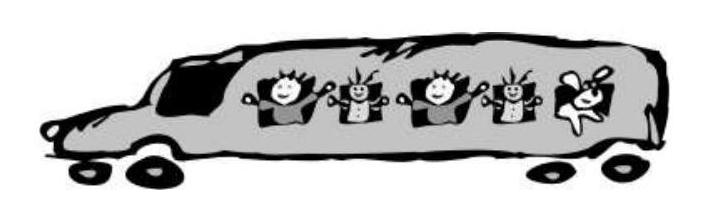A trip of the pupils to the zoo took 135 minutes. How many hours and minutes does it make? Choices: ['3 h 5 min', '2 h 15 min', '1 h 35 min', '2 h 35 min', '3 h 35 min'] The correct answer is '2 h 15 min'. To convert 135 minutes into hours and minutes, you divide 135 by 60, which gives you 2 hours because 60 minutes make up 1 hour. The remainder is 15 minutes. Therefore, 135 minutes is equivalent to 2 hours and 15 minutes. 